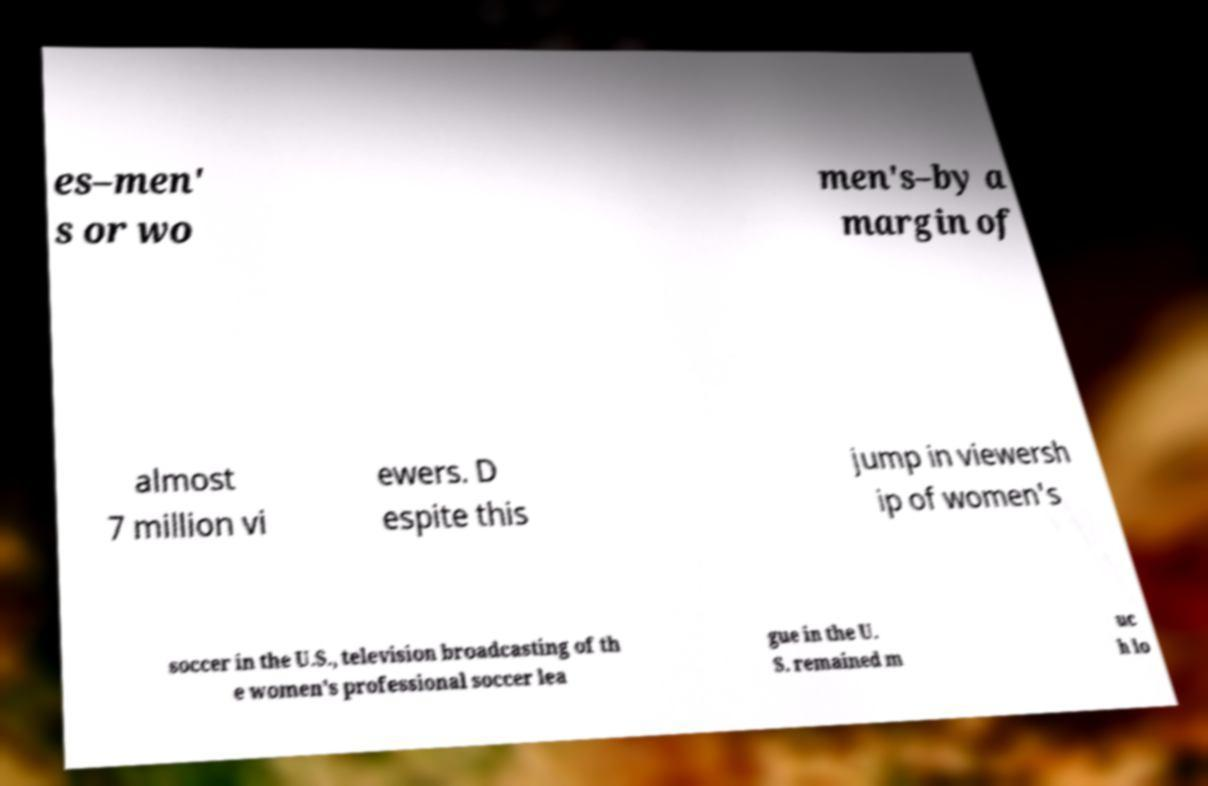Please read and relay the text visible in this image. What does it say? es–men' s or wo men's–by a margin of almost 7 million vi ewers. D espite this jump in viewersh ip of women's soccer in the U.S., television broadcasting of th e women's professional soccer lea gue in the U. S. remained m uc h lo 